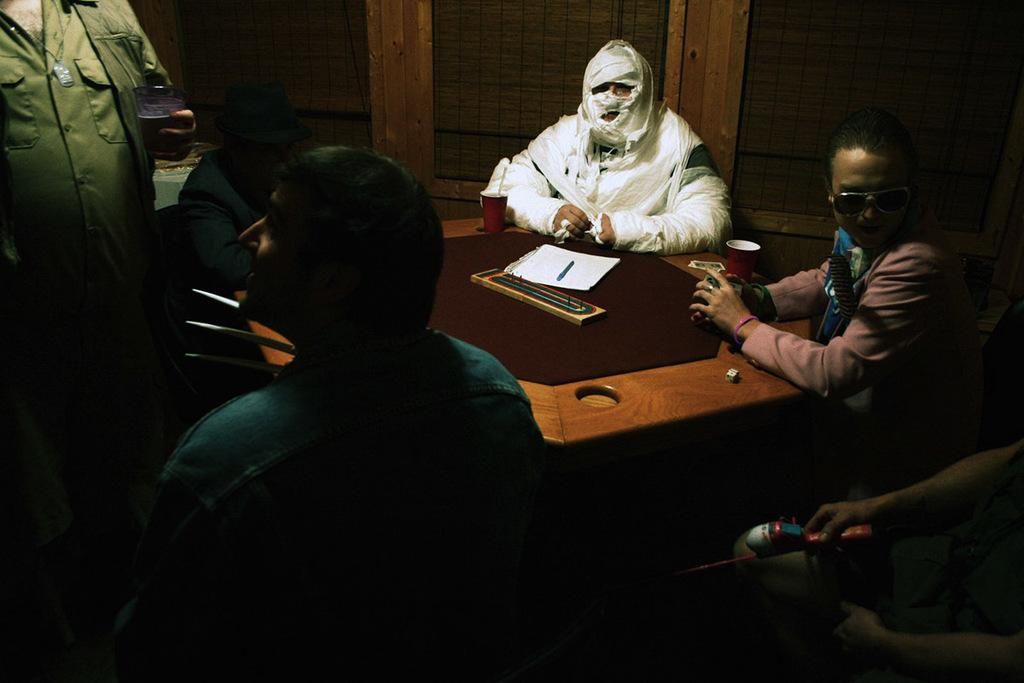How many people are in the image? There is a group of people in the image. What are the people in the image doing? The people are sitting around a table. Can you describe the appearance of one person in the group? One person in the group has a bandage on their whole body. What items are on the table with the group? There is a paper, a pen, and other unspecified objects on the table. What type of straw is being used by the person with the bandage? There is no straw present in the image. How does the nerve injury of the person with the bandage affect their ability to participate in the group activity? There is no mention of a nerve injury in the image or the provided facts. Is there a deer visible in the image? No, there is no deer present in the image. 